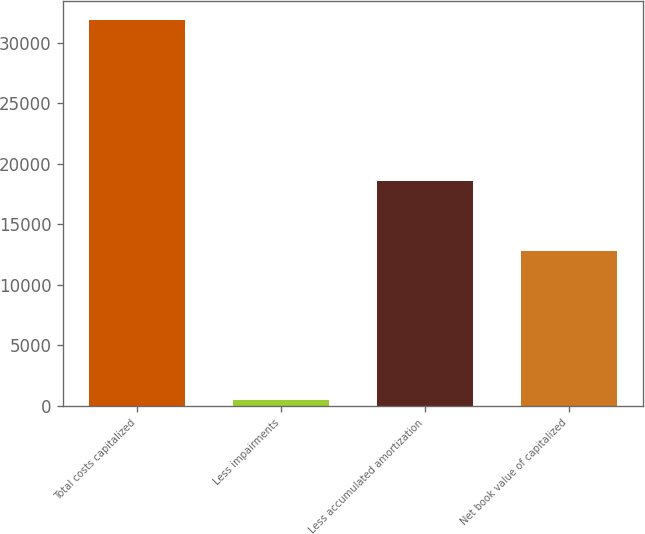<chart> <loc_0><loc_0><loc_500><loc_500><bar_chart><fcel>Total costs capitalized<fcel>Less impairments<fcel>Less accumulated amortization<fcel>Net book value of capitalized<nl><fcel>31856<fcel>485<fcel>18598<fcel>12773<nl></chart> 